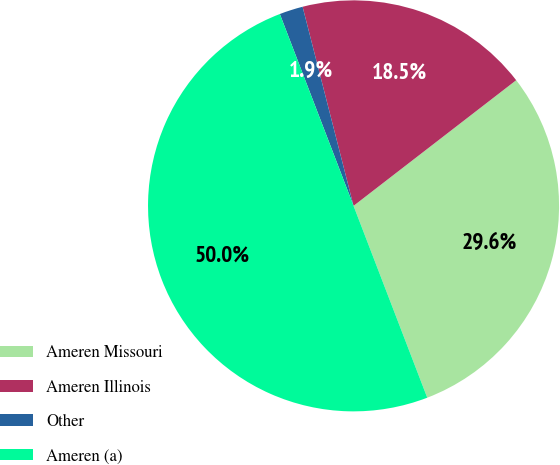Convert chart. <chart><loc_0><loc_0><loc_500><loc_500><pie_chart><fcel>Ameren Missouri<fcel>Ameren Illinois<fcel>Other<fcel>Ameren (a)<nl><fcel>29.63%<fcel>18.52%<fcel>1.85%<fcel>50.0%<nl></chart> 